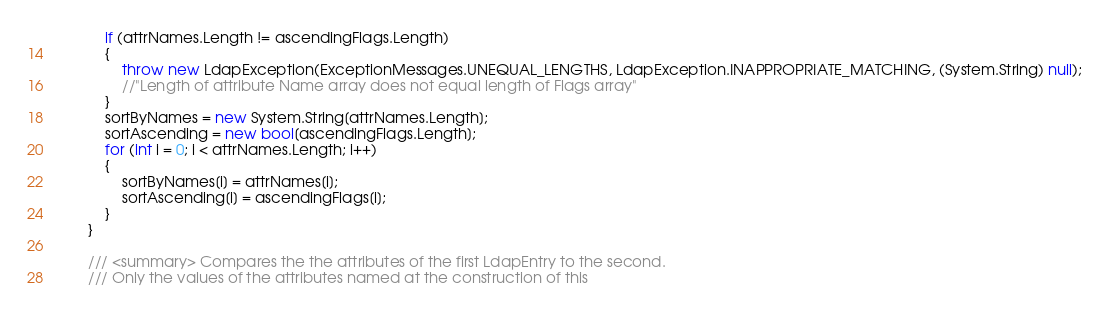<code> <loc_0><loc_0><loc_500><loc_500><_C#_>			if (attrNames.Length != ascendingFlags.Length)
			{
				throw new LdapException(ExceptionMessages.UNEQUAL_LENGTHS, LdapException.INAPPROPRIATE_MATCHING, (System.String) null);
				//"Length of attribute Name array does not equal length of Flags array"
			}
			sortByNames = new System.String[attrNames.Length];
			sortAscending = new bool[ascendingFlags.Length];
			for (int i = 0; i < attrNames.Length; i++)
			{
				sortByNames[i] = attrNames[i];
				sortAscending[i] = ascendingFlags[i];
			}
		}
		
		/// <summary> Compares the the attributes of the first LdapEntry to the second.
		/// Only the values of the attributes named at the construction of this</code> 